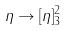<formula> <loc_0><loc_0><loc_500><loc_500>\eta \rightarrow [ \eta ] _ { 3 } ^ { 2 }</formula> 